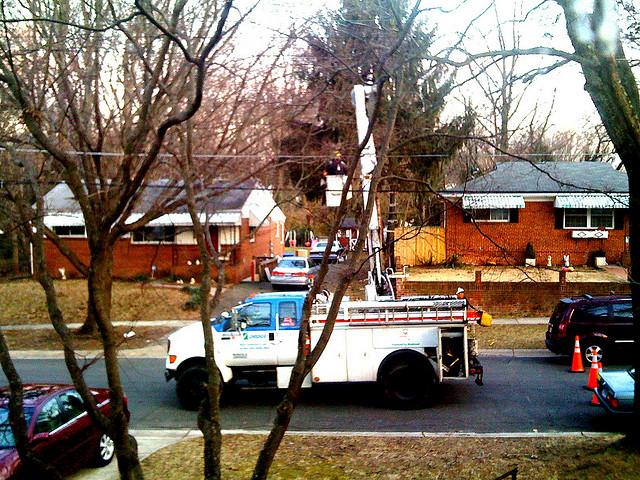Was this photo taken in the middle of summer?
Short answer required. No. What color is the car in the lower left picture?
Keep it brief. Red. Are there trees?
Concise answer only. Yes. 